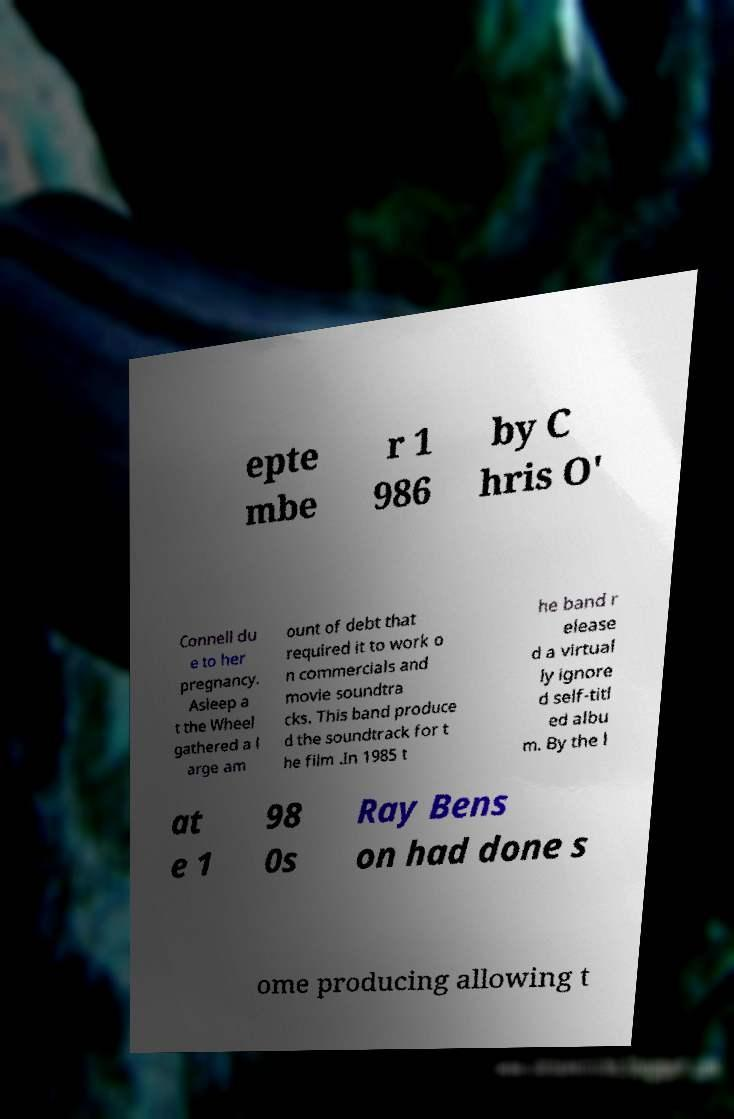I need the written content from this picture converted into text. Can you do that? epte mbe r 1 986 by C hris O' Connell du e to her pregnancy. Asleep a t the Wheel gathered a l arge am ount of debt that required it to work o n commercials and movie soundtra cks. This band produce d the soundtrack for t he film .In 1985 t he band r elease d a virtual ly ignore d self-titl ed albu m. By the l at e 1 98 0s Ray Bens on had done s ome producing allowing t 